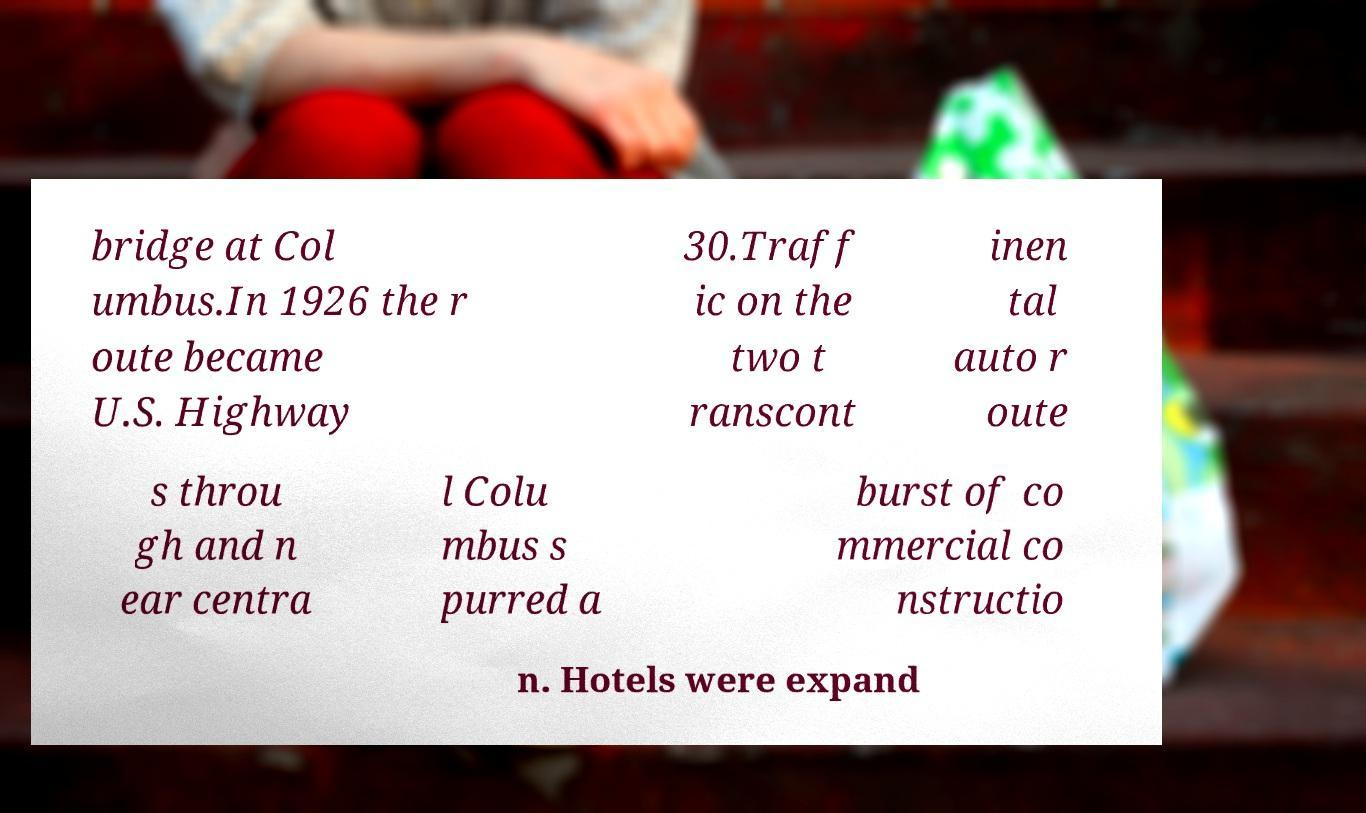Could you assist in decoding the text presented in this image and type it out clearly? bridge at Col umbus.In 1926 the r oute became U.S. Highway 30.Traff ic on the two t ranscont inen tal auto r oute s throu gh and n ear centra l Colu mbus s purred a burst of co mmercial co nstructio n. Hotels were expand 